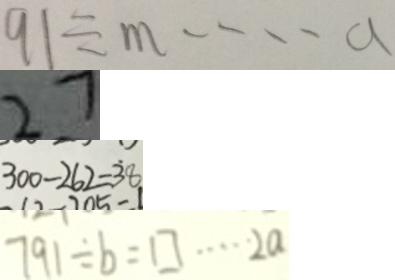Convert formula to latex. <formula><loc_0><loc_0><loc_500><loc_500>9 1 \div m \cdots a 
 2 7 
 3 0 0 - 2 6 2 = \dot { 3 } 8 
 7 9 1 \div b = \square \cdots 2 a</formula> 